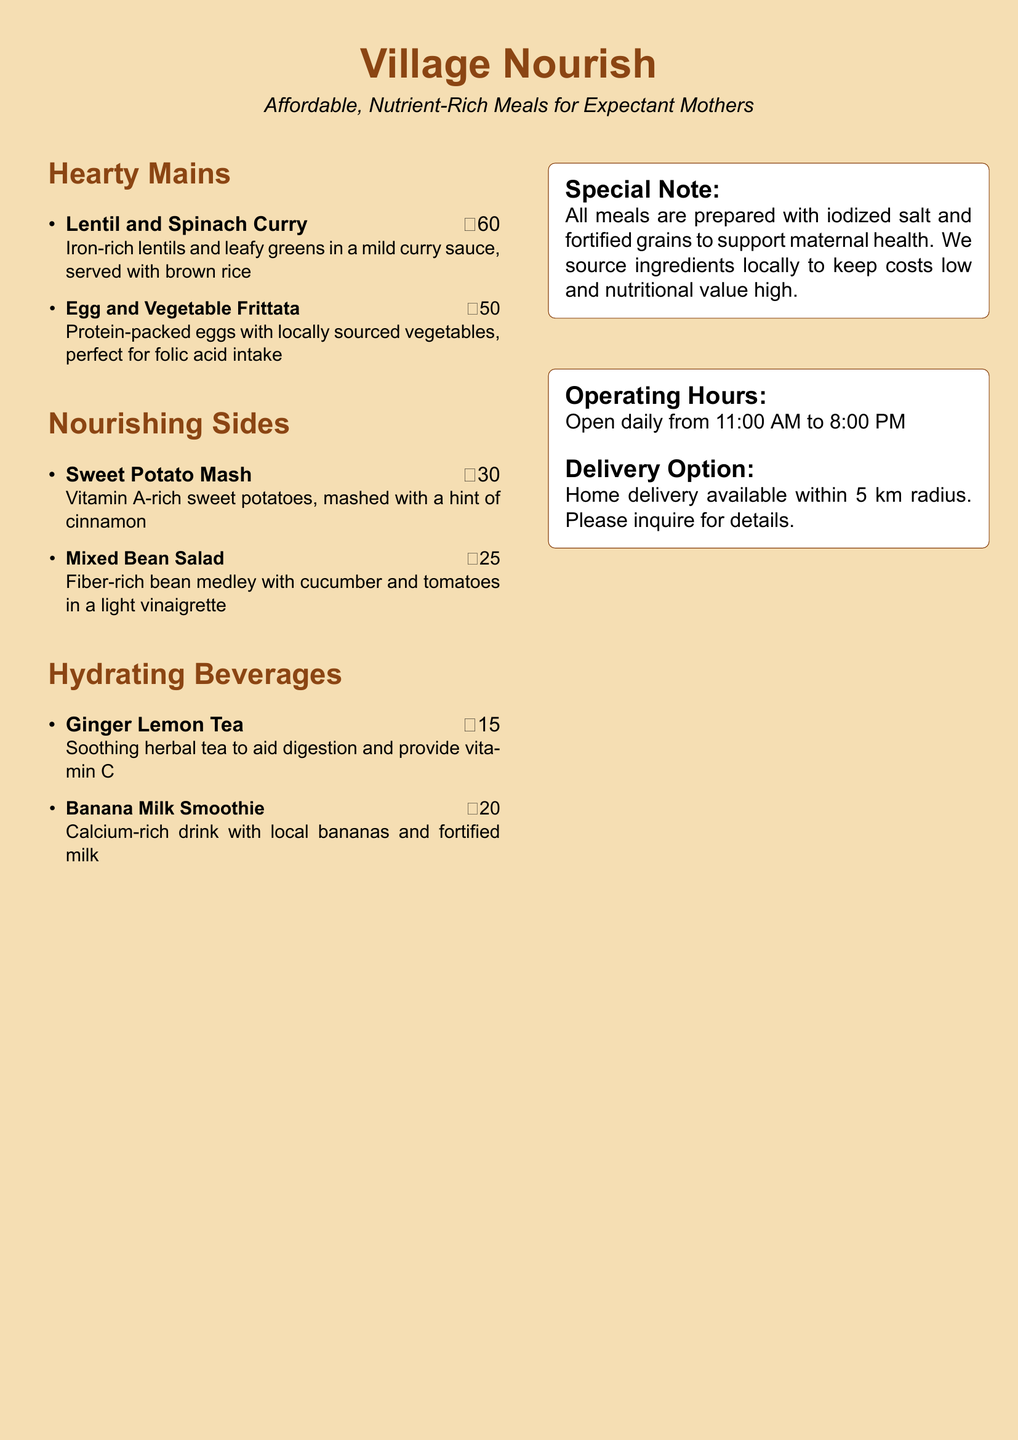What is the name of the restaurant? The document presents a menu for a restaurant called "Village Nourish."
Answer: Village Nourish What is the price of the Lentil and Spinach Curry? The menu lists the price of the Lentil and Spinach Curry as ₹60.
Answer: ₹60 What is a nutrient-rich ingredient in the Egg and Vegetable Frittata? The description mentions protein-packed eggs, relevant to nutritional needs during pregnancy.
Answer: Eggs What time does the restaurant open? The operating hours section states that the restaurant opens daily from 11:00 AM.
Answer: 11:00 AM What does the Ginger Lemon Tea aid in? The menu describes the Ginger Lemon Tea as soothing and aiding digestion, providing context to its benefits.
Answer: Digestion How much is the Banana Milk Smoothie? The menu lists the price of the Banana Milk Smoothie as ₹20.
Answer: ₹20 What type of salt is used in meal preparations? The special note highlights that all meals are prepared with iodized salt, specifying an important detail for health.
Answer: Iodized salt What is included in the Mixed Bean Salad? The description indicates that the Mixed Bean Salad contains a fiber-rich bean medley with cucumber and tomatoes.
Answer: Bean medley Is home delivery available? The document confirms that home delivery is available within a 5 km radius, answering the accessibility question.
Answer: Yes 